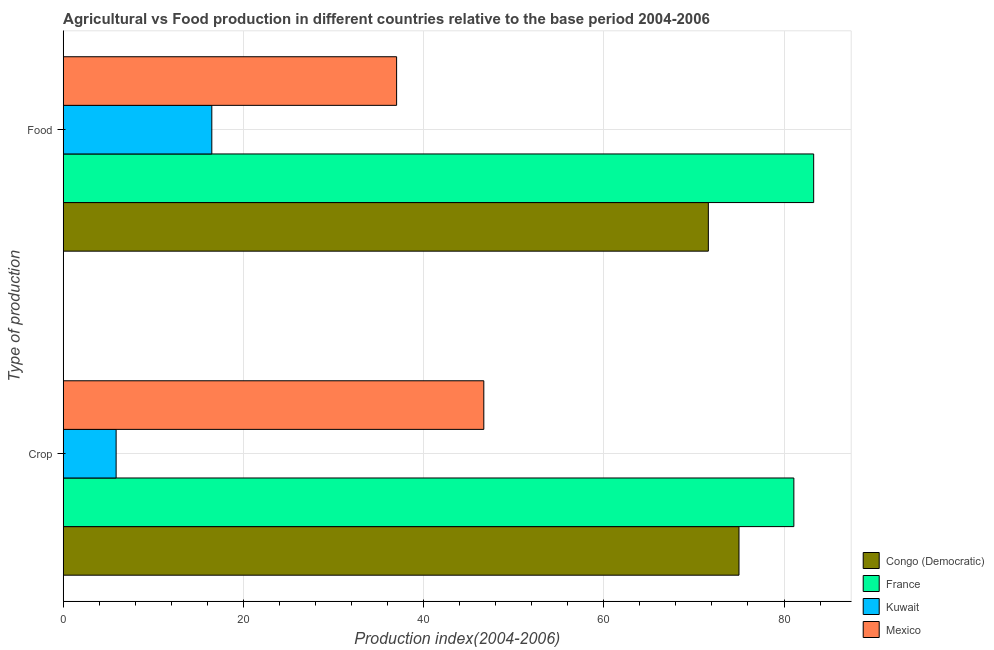Are the number of bars per tick equal to the number of legend labels?
Your answer should be very brief. Yes. What is the label of the 1st group of bars from the top?
Offer a very short reply. Food. What is the crop production index in France?
Make the answer very short. 81.09. Across all countries, what is the maximum food production index?
Ensure brevity in your answer.  83.29. Across all countries, what is the minimum food production index?
Give a very brief answer. 16.49. In which country was the crop production index maximum?
Make the answer very short. France. In which country was the crop production index minimum?
Keep it short and to the point. Kuwait. What is the total crop production index in the graph?
Your response must be concise. 208.64. What is the difference between the food production index in Congo (Democratic) and that in Kuwait?
Offer a very short reply. 55.11. What is the difference between the food production index in Mexico and the crop production index in Congo (Democratic)?
Provide a short and direct response. -38. What is the average food production index per country?
Your response must be concise. 52.09. What is the difference between the crop production index and food production index in Kuwait?
Provide a short and direct response. -10.62. What is the ratio of the crop production index in France to that in Kuwait?
Offer a terse response. 13.81. Is the food production index in Congo (Democratic) less than that in Mexico?
Your answer should be compact. No. What does the 4th bar from the top in Food represents?
Offer a very short reply. Congo (Democratic). What does the 3rd bar from the bottom in Crop represents?
Keep it short and to the point. Kuwait. How many countries are there in the graph?
Offer a very short reply. 4. Does the graph contain any zero values?
Provide a succinct answer. No. Does the graph contain grids?
Offer a very short reply. Yes. Where does the legend appear in the graph?
Your response must be concise. Bottom right. How many legend labels are there?
Provide a succinct answer. 4. How are the legend labels stacked?
Provide a short and direct response. Vertical. What is the title of the graph?
Give a very brief answer. Agricultural vs Food production in different countries relative to the base period 2004-2006. Does "Other small states" appear as one of the legend labels in the graph?
Offer a very short reply. No. What is the label or title of the X-axis?
Ensure brevity in your answer.  Production index(2004-2006). What is the label or title of the Y-axis?
Ensure brevity in your answer.  Type of production. What is the Production index(2004-2006) of France in Crop?
Your response must be concise. 81.09. What is the Production index(2004-2006) of Kuwait in Crop?
Your answer should be very brief. 5.87. What is the Production index(2004-2006) in Mexico in Crop?
Keep it short and to the point. 46.68. What is the Production index(2004-2006) of Congo (Democratic) in Food?
Ensure brevity in your answer.  71.6. What is the Production index(2004-2006) in France in Food?
Provide a short and direct response. 83.29. What is the Production index(2004-2006) of Kuwait in Food?
Offer a terse response. 16.49. Across all Type of production, what is the maximum Production index(2004-2006) of France?
Offer a terse response. 83.29. Across all Type of production, what is the maximum Production index(2004-2006) of Kuwait?
Ensure brevity in your answer.  16.49. Across all Type of production, what is the maximum Production index(2004-2006) of Mexico?
Provide a succinct answer. 46.68. Across all Type of production, what is the minimum Production index(2004-2006) of Congo (Democratic)?
Provide a short and direct response. 71.6. Across all Type of production, what is the minimum Production index(2004-2006) in France?
Your answer should be very brief. 81.09. Across all Type of production, what is the minimum Production index(2004-2006) of Kuwait?
Your answer should be very brief. 5.87. Across all Type of production, what is the minimum Production index(2004-2006) of Mexico?
Your answer should be compact. 37. What is the total Production index(2004-2006) of Congo (Democratic) in the graph?
Offer a very short reply. 146.6. What is the total Production index(2004-2006) of France in the graph?
Provide a short and direct response. 164.38. What is the total Production index(2004-2006) of Kuwait in the graph?
Make the answer very short. 22.36. What is the total Production index(2004-2006) of Mexico in the graph?
Provide a short and direct response. 83.68. What is the difference between the Production index(2004-2006) in Congo (Democratic) in Crop and that in Food?
Offer a very short reply. 3.4. What is the difference between the Production index(2004-2006) of France in Crop and that in Food?
Your answer should be compact. -2.2. What is the difference between the Production index(2004-2006) in Kuwait in Crop and that in Food?
Offer a terse response. -10.62. What is the difference between the Production index(2004-2006) in Mexico in Crop and that in Food?
Your response must be concise. 9.68. What is the difference between the Production index(2004-2006) in Congo (Democratic) in Crop and the Production index(2004-2006) in France in Food?
Offer a terse response. -8.29. What is the difference between the Production index(2004-2006) of Congo (Democratic) in Crop and the Production index(2004-2006) of Kuwait in Food?
Offer a terse response. 58.51. What is the difference between the Production index(2004-2006) of France in Crop and the Production index(2004-2006) of Kuwait in Food?
Ensure brevity in your answer.  64.6. What is the difference between the Production index(2004-2006) in France in Crop and the Production index(2004-2006) in Mexico in Food?
Keep it short and to the point. 44.09. What is the difference between the Production index(2004-2006) of Kuwait in Crop and the Production index(2004-2006) of Mexico in Food?
Your answer should be compact. -31.13. What is the average Production index(2004-2006) in Congo (Democratic) per Type of production?
Provide a short and direct response. 73.3. What is the average Production index(2004-2006) in France per Type of production?
Offer a terse response. 82.19. What is the average Production index(2004-2006) of Kuwait per Type of production?
Ensure brevity in your answer.  11.18. What is the average Production index(2004-2006) in Mexico per Type of production?
Provide a succinct answer. 41.84. What is the difference between the Production index(2004-2006) in Congo (Democratic) and Production index(2004-2006) in France in Crop?
Provide a succinct answer. -6.09. What is the difference between the Production index(2004-2006) in Congo (Democratic) and Production index(2004-2006) in Kuwait in Crop?
Offer a terse response. 69.13. What is the difference between the Production index(2004-2006) of Congo (Democratic) and Production index(2004-2006) of Mexico in Crop?
Your answer should be very brief. 28.32. What is the difference between the Production index(2004-2006) in France and Production index(2004-2006) in Kuwait in Crop?
Give a very brief answer. 75.22. What is the difference between the Production index(2004-2006) in France and Production index(2004-2006) in Mexico in Crop?
Your answer should be compact. 34.41. What is the difference between the Production index(2004-2006) in Kuwait and Production index(2004-2006) in Mexico in Crop?
Offer a very short reply. -40.81. What is the difference between the Production index(2004-2006) in Congo (Democratic) and Production index(2004-2006) in France in Food?
Provide a succinct answer. -11.69. What is the difference between the Production index(2004-2006) of Congo (Democratic) and Production index(2004-2006) of Kuwait in Food?
Provide a short and direct response. 55.11. What is the difference between the Production index(2004-2006) of Congo (Democratic) and Production index(2004-2006) of Mexico in Food?
Keep it short and to the point. 34.6. What is the difference between the Production index(2004-2006) in France and Production index(2004-2006) in Kuwait in Food?
Ensure brevity in your answer.  66.8. What is the difference between the Production index(2004-2006) of France and Production index(2004-2006) of Mexico in Food?
Your answer should be compact. 46.29. What is the difference between the Production index(2004-2006) of Kuwait and Production index(2004-2006) of Mexico in Food?
Provide a succinct answer. -20.51. What is the ratio of the Production index(2004-2006) of Congo (Democratic) in Crop to that in Food?
Your answer should be compact. 1.05. What is the ratio of the Production index(2004-2006) in France in Crop to that in Food?
Offer a terse response. 0.97. What is the ratio of the Production index(2004-2006) of Kuwait in Crop to that in Food?
Your answer should be very brief. 0.36. What is the ratio of the Production index(2004-2006) in Mexico in Crop to that in Food?
Provide a succinct answer. 1.26. What is the difference between the highest and the second highest Production index(2004-2006) in Congo (Democratic)?
Ensure brevity in your answer.  3.4. What is the difference between the highest and the second highest Production index(2004-2006) in France?
Ensure brevity in your answer.  2.2. What is the difference between the highest and the second highest Production index(2004-2006) of Kuwait?
Your response must be concise. 10.62. What is the difference between the highest and the second highest Production index(2004-2006) in Mexico?
Your answer should be very brief. 9.68. What is the difference between the highest and the lowest Production index(2004-2006) in Kuwait?
Offer a terse response. 10.62. What is the difference between the highest and the lowest Production index(2004-2006) of Mexico?
Offer a terse response. 9.68. 